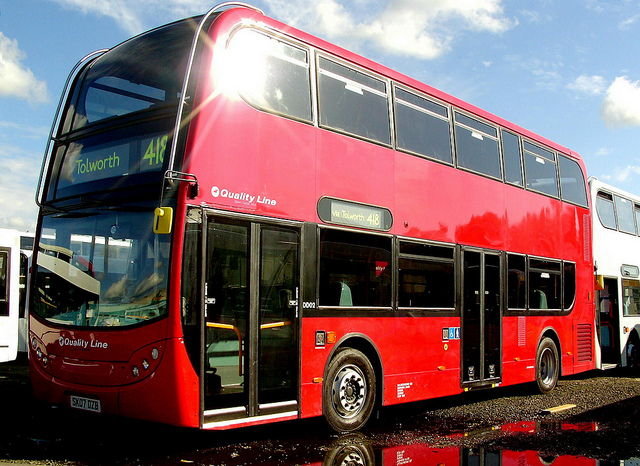Identify the text contained in this image. Tolworth 418 Quality Line coca 418 LINE Quality 